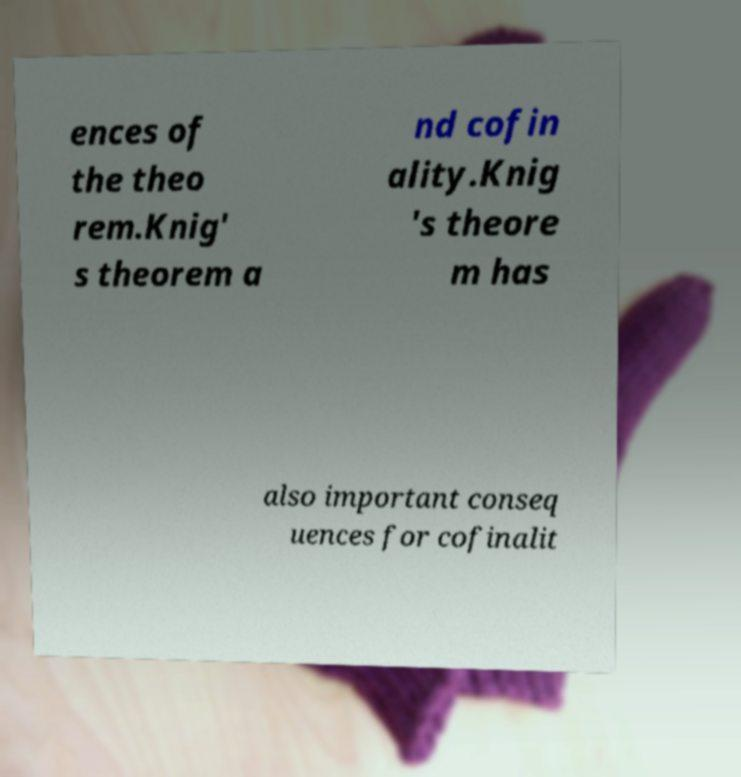Please identify and transcribe the text found in this image. ences of the theo rem.Knig' s theorem a nd cofin ality.Knig 's theore m has also important conseq uences for cofinalit 